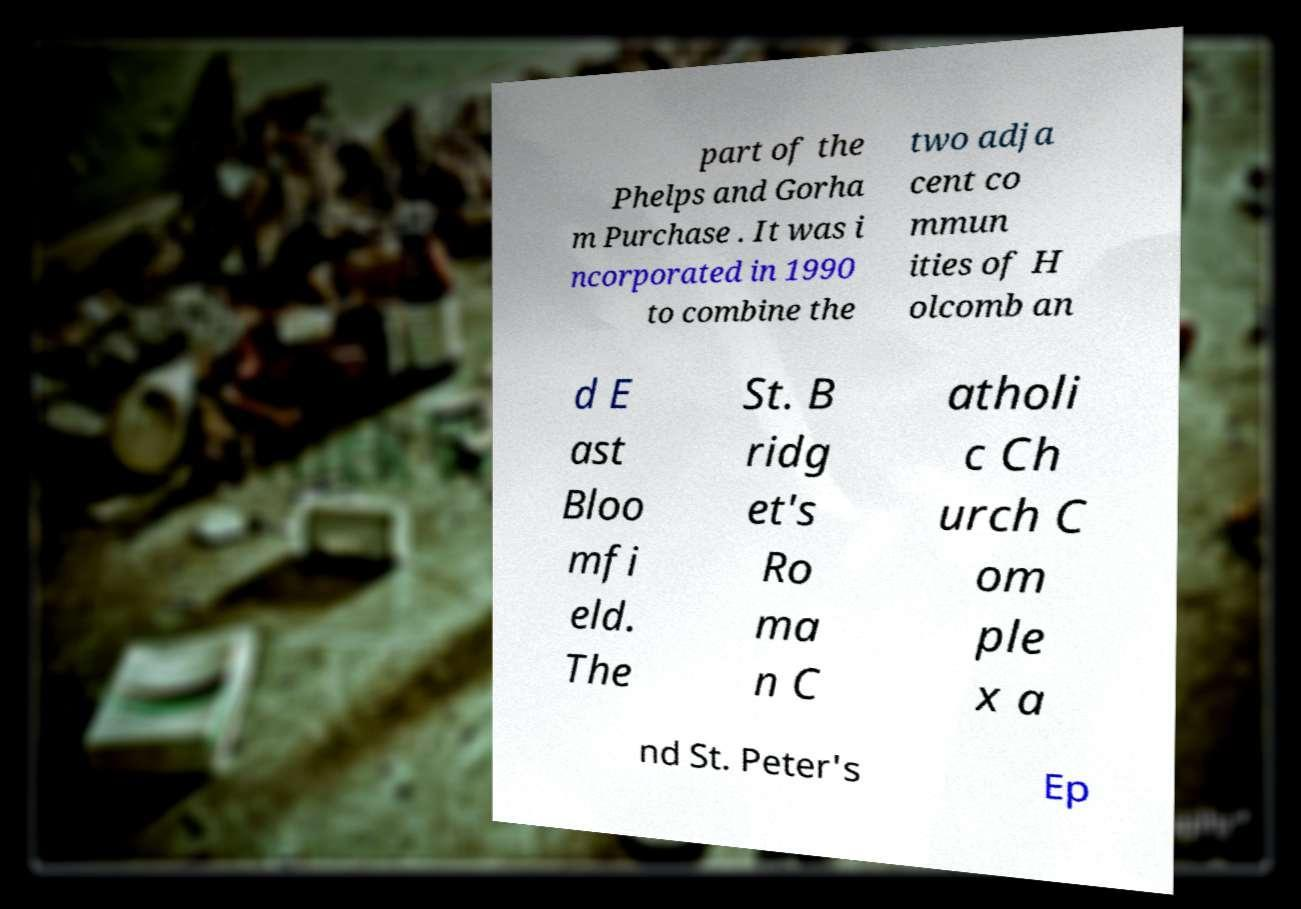Can you read and provide the text displayed in the image?This photo seems to have some interesting text. Can you extract and type it out for me? part of the Phelps and Gorha m Purchase . It was i ncorporated in 1990 to combine the two adja cent co mmun ities of H olcomb an d E ast Bloo mfi eld. The St. B ridg et's Ro ma n C atholi c Ch urch C om ple x a nd St. Peter's Ep 